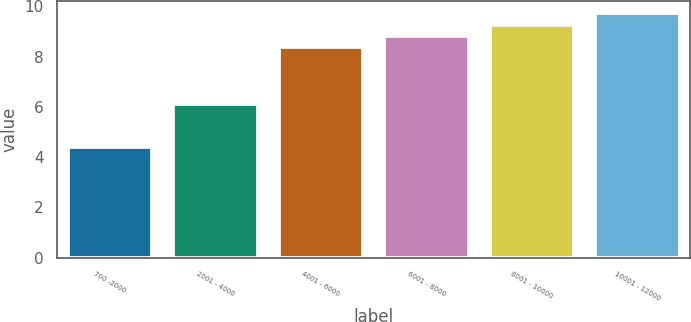Convert chart. <chart><loc_0><loc_0><loc_500><loc_500><bar_chart><fcel>700 -2000<fcel>2001 - 4000<fcel>4001 - 6000<fcel>6001 - 8000<fcel>8001 - 10000<fcel>10001 - 12000<nl><fcel>4.4<fcel>6.13<fcel>8.38<fcel>8.83<fcel>9.28<fcel>9.73<nl></chart> 